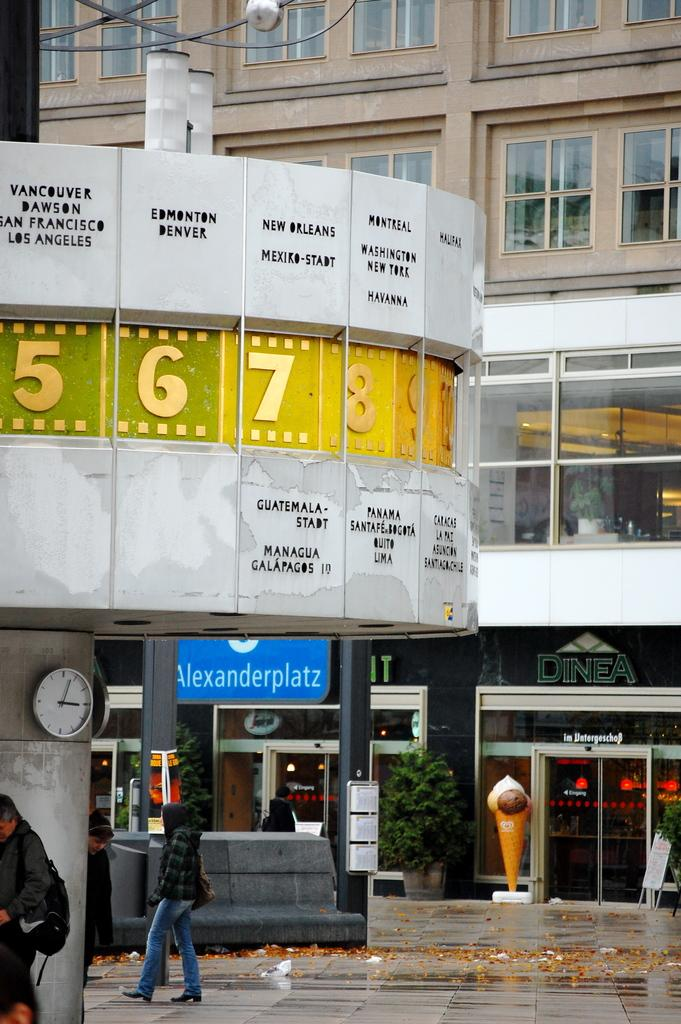What type of structure can be seen in the background of the image? There is a building with windows in the background of the image. What can be found in the image besides the building? There are stalls and people walking on the floor in the center of the image. What might be used for telling time in the image? There is a clock in the image. What type of clouds can be seen in the image? There are no clouds visible in the image. What word is written on the stalls in the image? The provided facts do not mention any specific words written on the stalls, so we cannot answer this question definitively. 